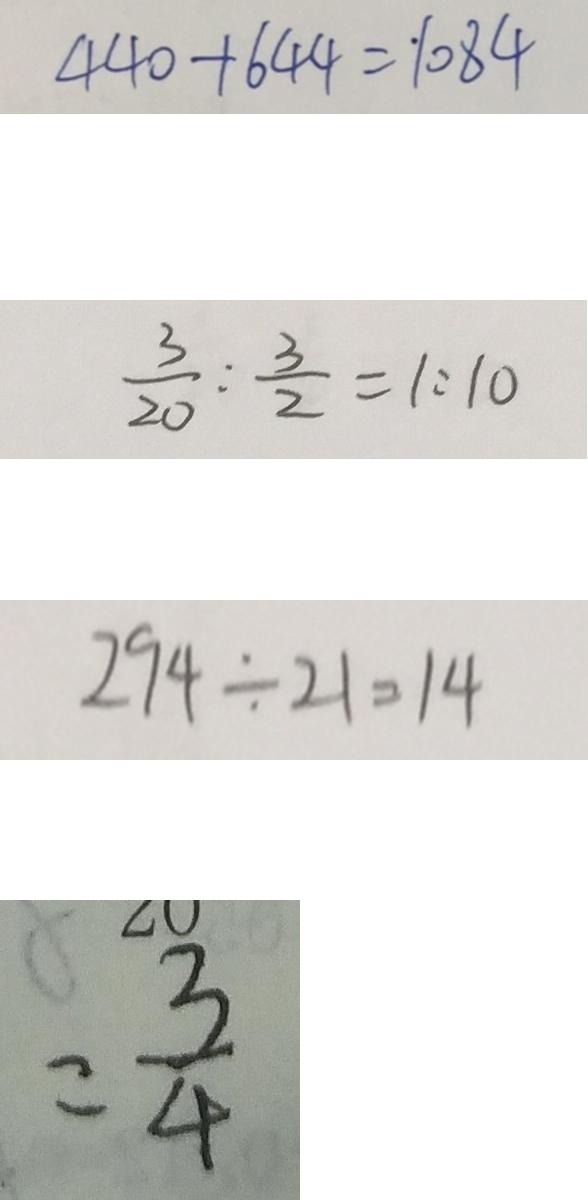<formula> <loc_0><loc_0><loc_500><loc_500>4 4 0 + 6 4 4 = 1 0 8 4 
 \frac { 3 } { 2 0 } : \frac { 3 } { 2 } = 1 : 1 0 
 2 9 4 \div 2 1 = 1 4 
 = \frac { 3 } { 4 }</formula> 